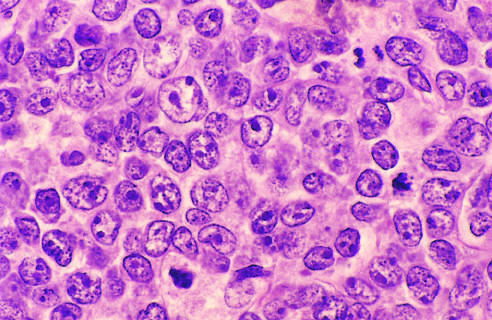what have large nuclei with open chromatin and prominent nucleoli?
Answer the question using a single word or phrase. The tumor cells 